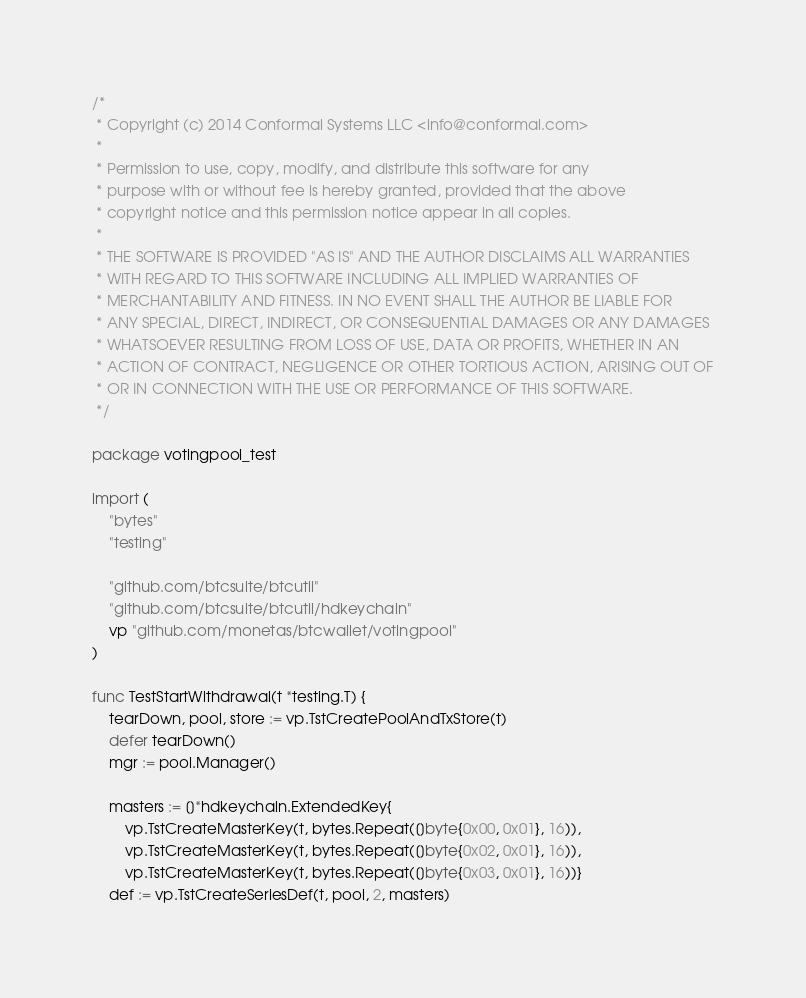Convert code to text. <code><loc_0><loc_0><loc_500><loc_500><_Go_>/*
 * Copyright (c) 2014 Conformal Systems LLC <info@conformal.com>
 *
 * Permission to use, copy, modify, and distribute this software for any
 * purpose with or without fee is hereby granted, provided that the above
 * copyright notice and this permission notice appear in all copies.
 *
 * THE SOFTWARE IS PROVIDED "AS IS" AND THE AUTHOR DISCLAIMS ALL WARRANTIES
 * WITH REGARD TO THIS SOFTWARE INCLUDING ALL IMPLIED WARRANTIES OF
 * MERCHANTABILITY AND FITNESS. IN NO EVENT SHALL THE AUTHOR BE LIABLE FOR
 * ANY SPECIAL, DIRECT, INDIRECT, OR CONSEQUENTIAL DAMAGES OR ANY DAMAGES
 * WHATSOEVER RESULTING FROM LOSS OF USE, DATA OR PROFITS, WHETHER IN AN
 * ACTION OF CONTRACT, NEGLIGENCE OR OTHER TORTIOUS ACTION, ARISING OUT OF
 * OR IN CONNECTION WITH THE USE OR PERFORMANCE OF THIS SOFTWARE.
 */

package votingpool_test

import (
	"bytes"
	"testing"

	"github.com/btcsuite/btcutil"
	"github.com/btcsuite/btcutil/hdkeychain"
	vp "github.com/monetas/btcwallet/votingpool"
)

func TestStartWithdrawal(t *testing.T) {
	tearDown, pool, store := vp.TstCreatePoolAndTxStore(t)
	defer tearDown()
	mgr := pool.Manager()

	masters := []*hdkeychain.ExtendedKey{
		vp.TstCreateMasterKey(t, bytes.Repeat([]byte{0x00, 0x01}, 16)),
		vp.TstCreateMasterKey(t, bytes.Repeat([]byte{0x02, 0x01}, 16)),
		vp.TstCreateMasterKey(t, bytes.Repeat([]byte{0x03, 0x01}, 16))}
	def := vp.TstCreateSeriesDef(t, pool, 2, masters)</code> 